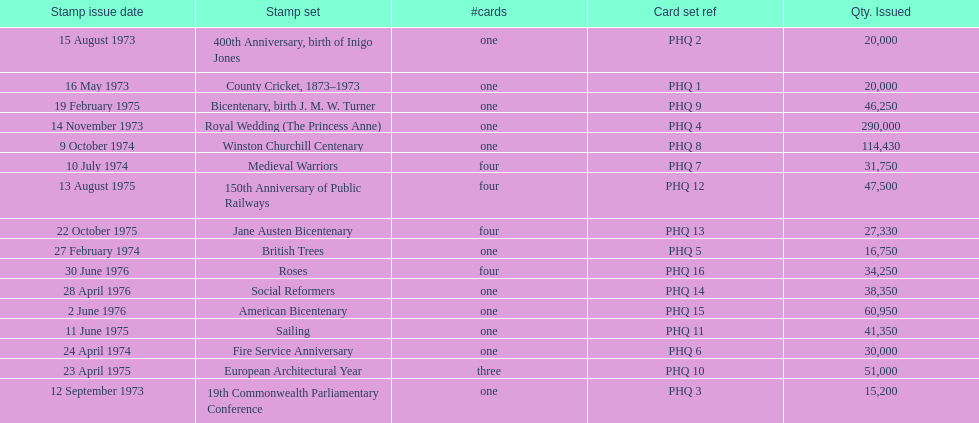Which stamp set had the greatest quantity issued? Royal Wedding (The Princess Anne). 